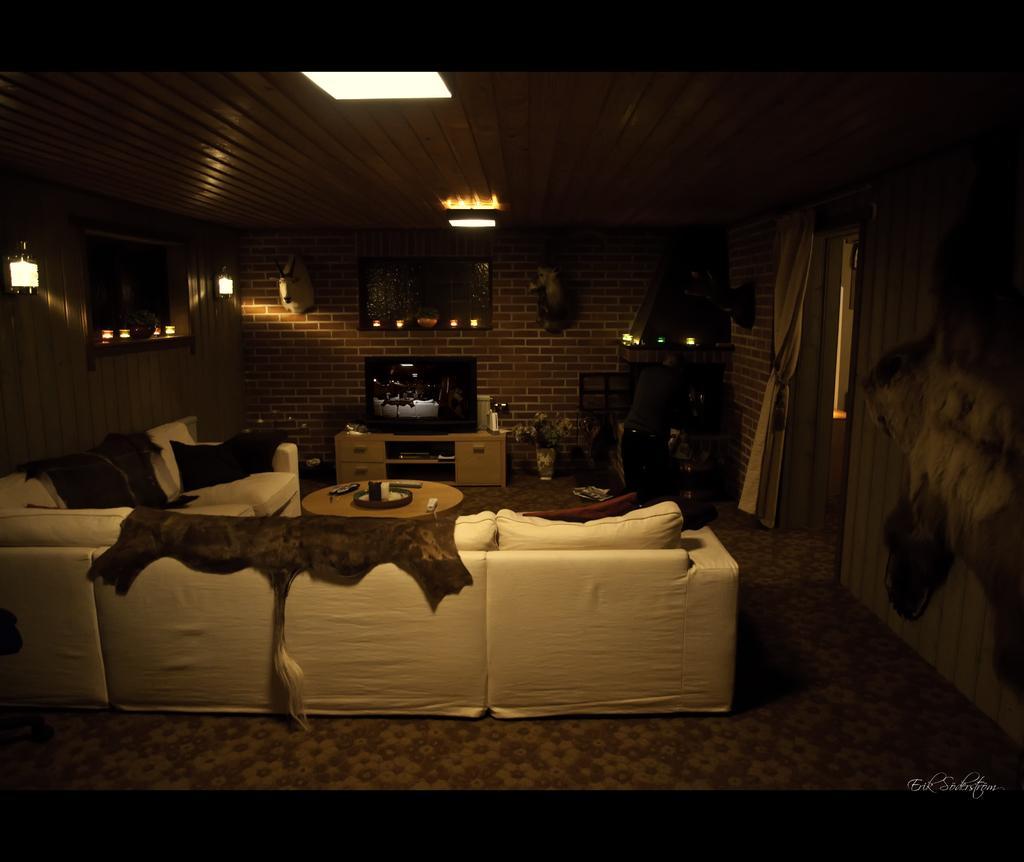Could you give a brief overview of what you see in this image? This looks like a living room. This is a couch with cushions on it. here is a small teapoy with few objects placed. This is a television on the television stand. This looks like a frame attached to the wall. This is a ceiling light attached to the rooftop. This looks like a curtain hanging. I can see a flower vase placed on the floor. These are the lamps,animal heads attached to the wall. 